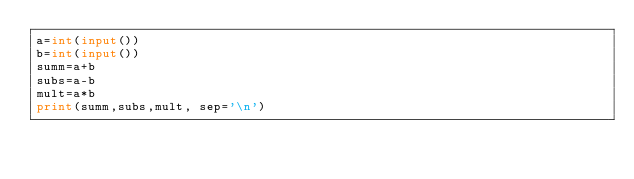<code> <loc_0><loc_0><loc_500><loc_500><_Python_>a=int(input())
b=int(input())
summ=a+b
subs=a-b
mult=a*b
print(summ,subs,mult, sep='\n')</code> 